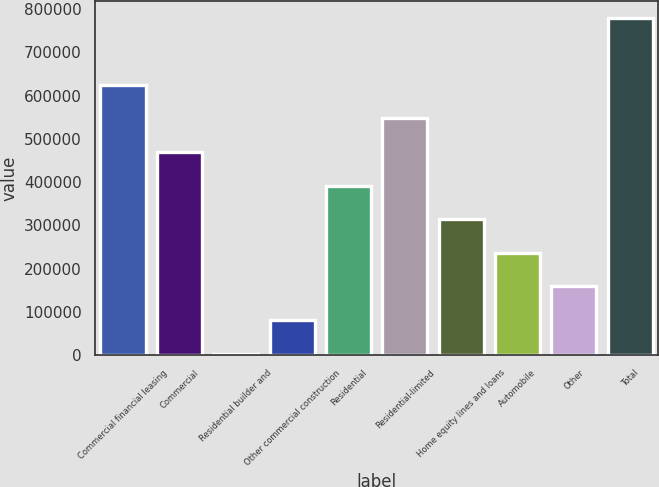<chart> <loc_0><loc_0><loc_500><loc_500><bar_chart><fcel>Commercial financial leasing<fcel>Commercial<fcel>Residential builder and<fcel>Other commercial construction<fcel>Residential<fcel>Residential-limited<fcel>Home equity lines and loans<fcel>Automobile<fcel>Other<fcel>Total<nl><fcel>625136<fcel>469681<fcel>3316<fcel>81043.5<fcel>391954<fcel>547408<fcel>314226<fcel>236498<fcel>158771<fcel>780591<nl></chart> 